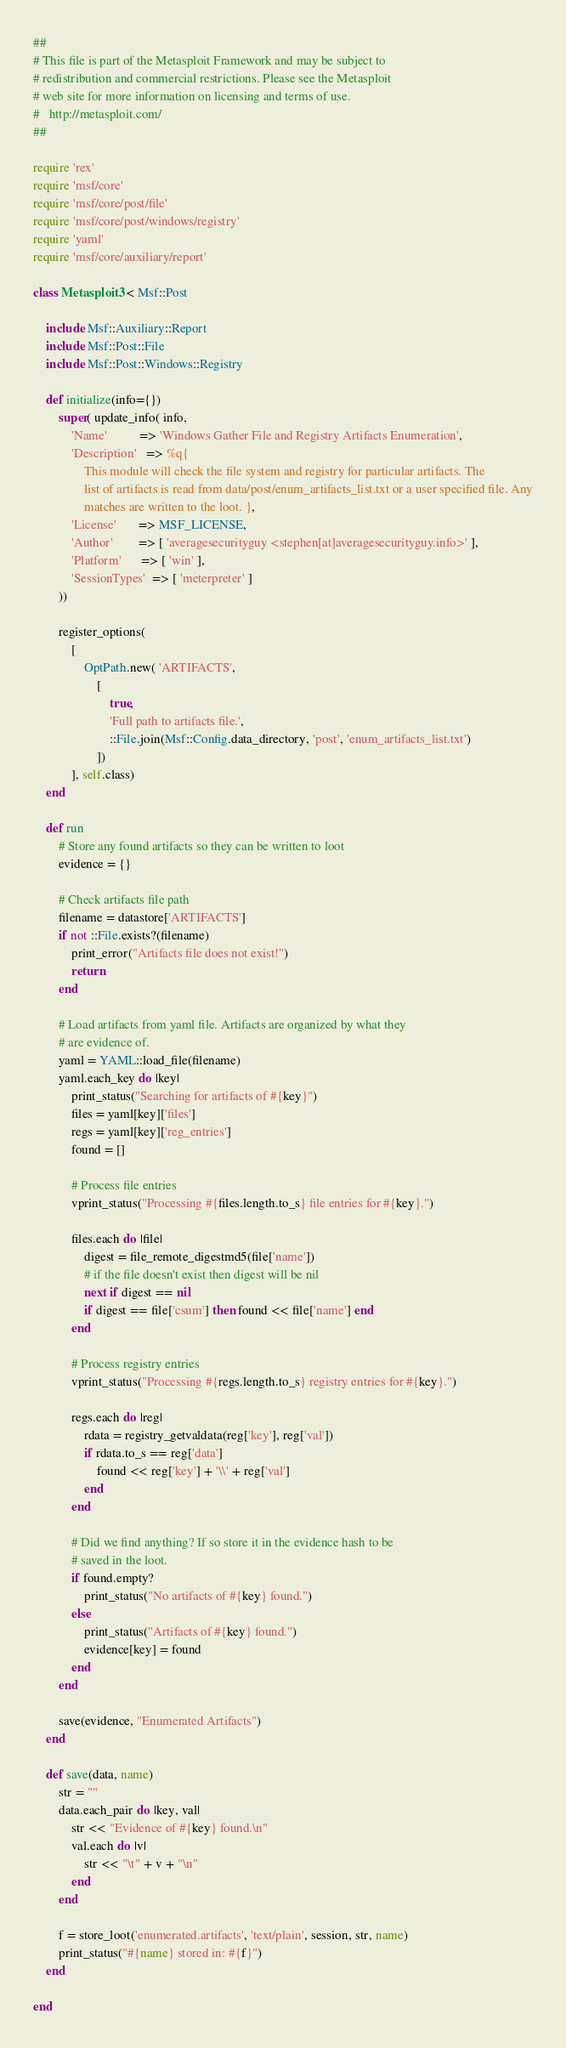Convert code to text. <code><loc_0><loc_0><loc_500><loc_500><_Ruby_>##
# This file is part of the Metasploit Framework and may be subject to
# redistribution and commercial restrictions. Please see the Metasploit
# web site for more information on licensing and terms of use.
#   http://metasploit.com/
##

require 'rex'
require 'msf/core'
require 'msf/core/post/file'
require 'msf/core/post/windows/registry'
require 'yaml'
require 'msf/core/auxiliary/report'

class Metasploit3 < Msf::Post

	include Msf::Auxiliary::Report
	include Msf::Post::File
	include Msf::Post::Windows::Registry

	def initialize(info={})
		super( update_info( info,
			'Name'          => 'Windows Gather File and Registry Artifacts Enumeration',
			'Description'   => %q{
				This module will check the file system and registry for particular artifacts. The
				list of artifacts is read from data/post/enum_artifacts_list.txt or a user specified file. Any
				matches are written to the loot. },
			'License'       => MSF_LICENSE,
			'Author'        => [ 'averagesecurityguy <stephen[at]averagesecurityguy.info>' ],
			'Platform'      => [ 'win' ],
			'SessionTypes'  => [ 'meterpreter' ]
		))

		register_options(
			[
				OptPath.new( 'ARTIFACTS',
					[
						true,
						'Full path to artifacts file.',
						::File.join(Msf::Config.data_directory, 'post', 'enum_artifacts_list.txt')
					])
			], self.class)
	end

	def run
		# Store any found artifacts so they can be written to loot
		evidence = {}

		# Check artifacts file path
		filename = datastore['ARTIFACTS']
		if not ::File.exists?(filename)
			print_error("Artifacts file does not exist!")
			return
		end

		# Load artifacts from yaml file. Artifacts are organized by what they
		# are evidence of.
		yaml = YAML::load_file(filename)
		yaml.each_key do |key|
			print_status("Searching for artifacts of #{key}")
			files = yaml[key]['files']
			regs = yaml[key]['reg_entries']
			found = []

			# Process file entries
			vprint_status("Processing #{files.length.to_s} file entries for #{key}.")

			files.each do |file|
				digest = file_remote_digestmd5(file['name'])
				# if the file doesn't exist then digest will be nil
				next if digest == nil
				if digest == file['csum'] then found << file['name'] end
			end

			# Process registry entries
			vprint_status("Processing #{regs.length.to_s} registry entries for #{key}.")

			regs.each do |reg|
				rdata = registry_getvaldata(reg['key'], reg['val'])
				if rdata.to_s == reg['data']
					found << reg['key'] + '\\' + reg['val']
				end
			end

			# Did we find anything? If so store it in the evidence hash to be
			# saved in the loot.
			if found.empty?
				print_status("No artifacts of #{key} found.")
			else
				print_status("Artifacts of #{key} found.")
				evidence[key] = found
			end
		end

		save(evidence, "Enumerated Artifacts")
	end

	def save(data, name)
		str = ""
		data.each_pair do |key, val|
			str << "Evidence of #{key} found.\n"
			val.each do |v|
				str << "\t" + v + "\n"
			end
		end

		f = store_loot('enumerated.artifacts', 'text/plain', session, str, name)
		print_status("#{name} stored in: #{f}")
	end

end
</code> 